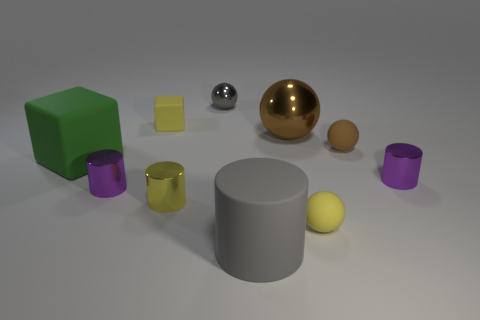Subtract all spheres. How many objects are left? 6 Add 5 gray cylinders. How many gray cylinders exist? 6 Subtract 0 green cylinders. How many objects are left? 10 Subtract all rubber spheres. Subtract all tiny yellow matte cubes. How many objects are left? 7 Add 4 big gray objects. How many big gray objects are left? 5 